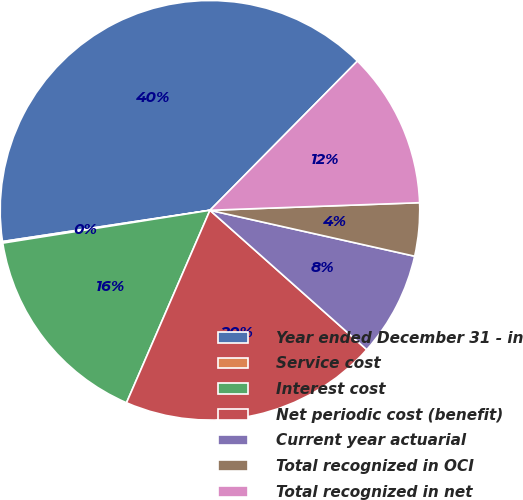<chart> <loc_0><loc_0><loc_500><loc_500><pie_chart><fcel>Year ended December 31 - in<fcel>Service cost<fcel>Interest cost<fcel>Net periodic cost (benefit)<fcel>Current year actuarial<fcel>Total recognized in OCI<fcel>Total recognized in net<nl><fcel>39.79%<fcel>0.12%<fcel>15.99%<fcel>19.95%<fcel>8.05%<fcel>4.09%<fcel>12.02%<nl></chart> 